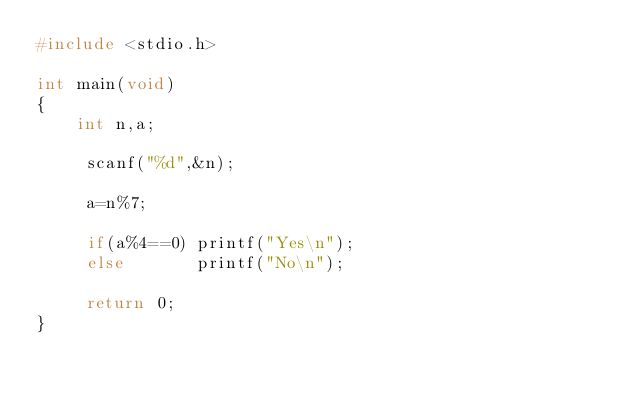<code> <loc_0><loc_0><loc_500><loc_500><_C_>#include <stdio.h>

int main(void)
{
    int n,a;
      
     scanf("%d",&n);
  
     a=n%7;
     
     if(a%4==0) printf("Yes\n");
     else       printf("No\n");
  
     return 0;
}  </code> 